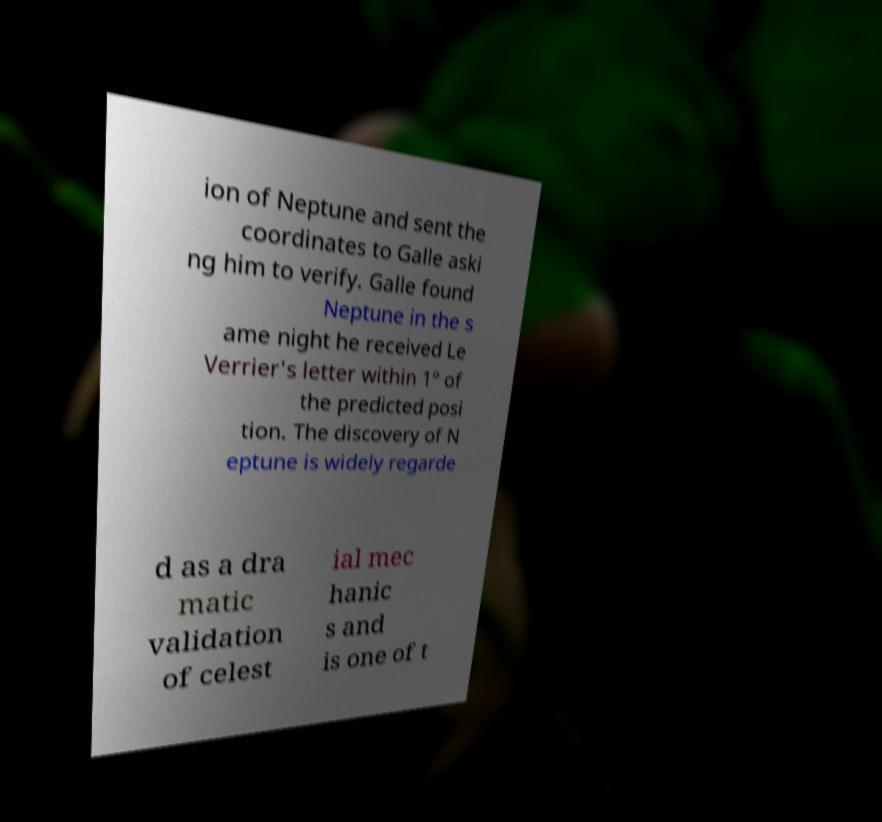Can you accurately transcribe the text from the provided image for me? ion of Neptune and sent the coordinates to Galle aski ng him to verify. Galle found Neptune in the s ame night he received Le Verrier's letter within 1° of the predicted posi tion. The discovery of N eptune is widely regarde d as a dra matic validation of celest ial mec hanic s and is one of t 